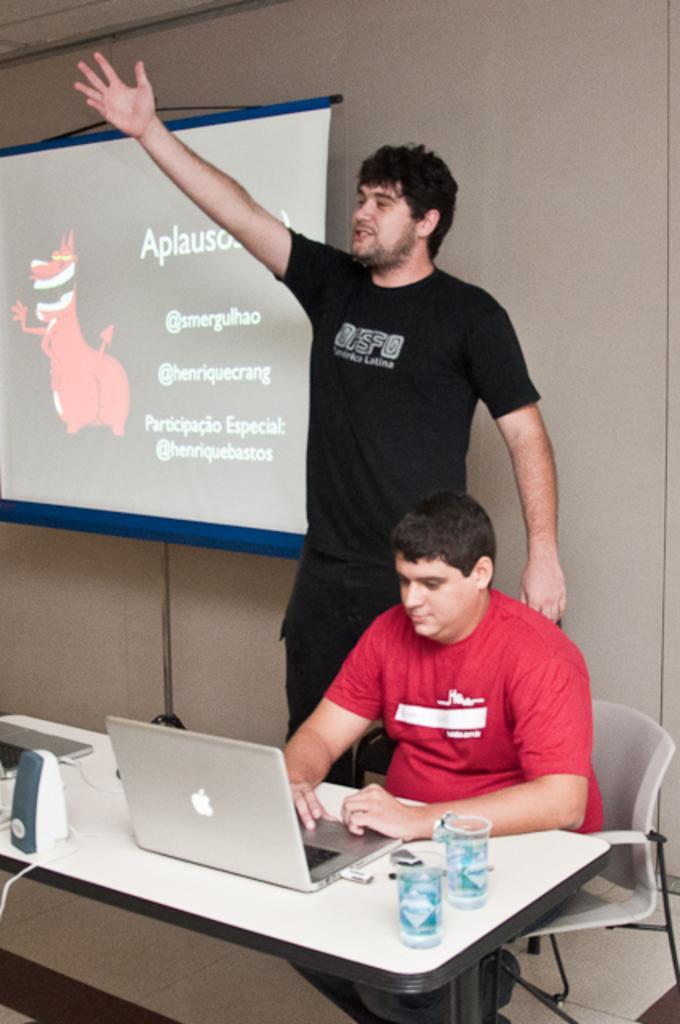In one or two sentences, can you explain what this image depicts? in this image the two persons are there one person is sitting on the chair and one person is standing and the person who is sitting doing something work on laptop back ground is there on the table the two glasses,microphones ,laptop and charger is there and the back ground is morning. 